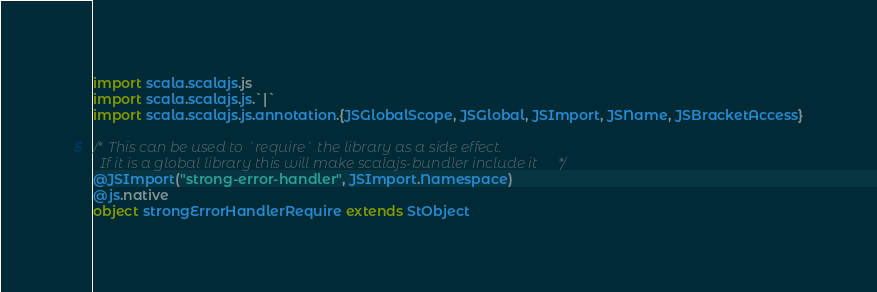Convert code to text. <code><loc_0><loc_0><loc_500><loc_500><_Scala_>import scala.scalajs.js
import scala.scalajs.js.`|`
import scala.scalajs.js.annotation.{JSGlobalScope, JSGlobal, JSImport, JSName, JSBracketAccess}

/* This can be used to `require` the library as a side effect.
  If it is a global library this will make scalajs-bundler include it */
@JSImport("strong-error-handler", JSImport.Namespace)
@js.native
object strongErrorHandlerRequire extends StObject
</code> 